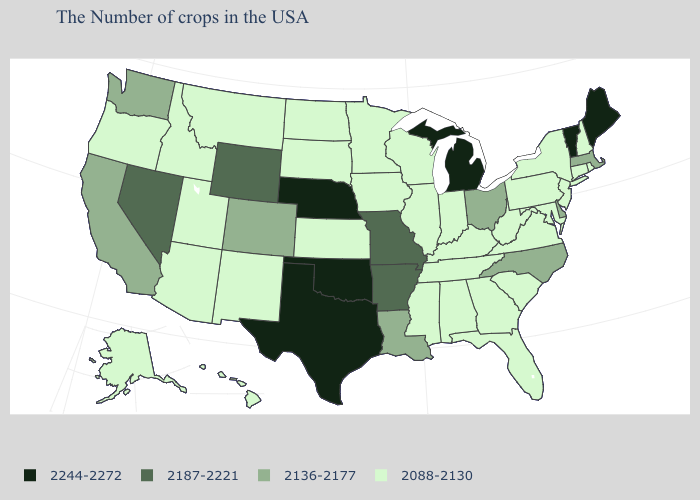What is the value of California?
Be succinct. 2136-2177. Does the first symbol in the legend represent the smallest category?
Keep it brief. No. What is the highest value in states that border Oklahoma?
Concise answer only. 2244-2272. Which states have the lowest value in the USA?
Keep it brief. Rhode Island, New Hampshire, Connecticut, New York, New Jersey, Maryland, Pennsylvania, Virginia, South Carolina, West Virginia, Florida, Georgia, Kentucky, Indiana, Alabama, Tennessee, Wisconsin, Illinois, Mississippi, Minnesota, Iowa, Kansas, South Dakota, North Dakota, New Mexico, Utah, Montana, Arizona, Idaho, Oregon, Alaska, Hawaii. What is the value of Minnesota?
Give a very brief answer. 2088-2130. What is the value of Massachusetts?
Give a very brief answer. 2136-2177. What is the lowest value in states that border Nevada?
Be succinct. 2088-2130. Name the states that have a value in the range 2244-2272?
Concise answer only. Maine, Vermont, Michigan, Nebraska, Oklahoma, Texas. Name the states that have a value in the range 2136-2177?
Answer briefly. Massachusetts, Delaware, North Carolina, Ohio, Louisiana, Colorado, California, Washington. What is the value of Maryland?
Answer briefly. 2088-2130. Name the states that have a value in the range 2088-2130?
Quick response, please. Rhode Island, New Hampshire, Connecticut, New York, New Jersey, Maryland, Pennsylvania, Virginia, South Carolina, West Virginia, Florida, Georgia, Kentucky, Indiana, Alabama, Tennessee, Wisconsin, Illinois, Mississippi, Minnesota, Iowa, Kansas, South Dakota, North Dakota, New Mexico, Utah, Montana, Arizona, Idaho, Oregon, Alaska, Hawaii. What is the lowest value in the USA?
Write a very short answer. 2088-2130. Which states have the lowest value in the South?
Quick response, please. Maryland, Virginia, South Carolina, West Virginia, Florida, Georgia, Kentucky, Alabama, Tennessee, Mississippi. What is the highest value in states that border Arizona?
Quick response, please. 2187-2221. What is the value of Idaho?
Concise answer only. 2088-2130. 